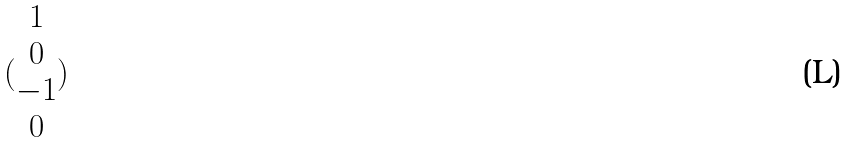Convert formula to latex. <formula><loc_0><loc_0><loc_500><loc_500>( \begin{matrix} 1 \\ 0 \\ - 1 \\ 0 \end{matrix} )</formula> 